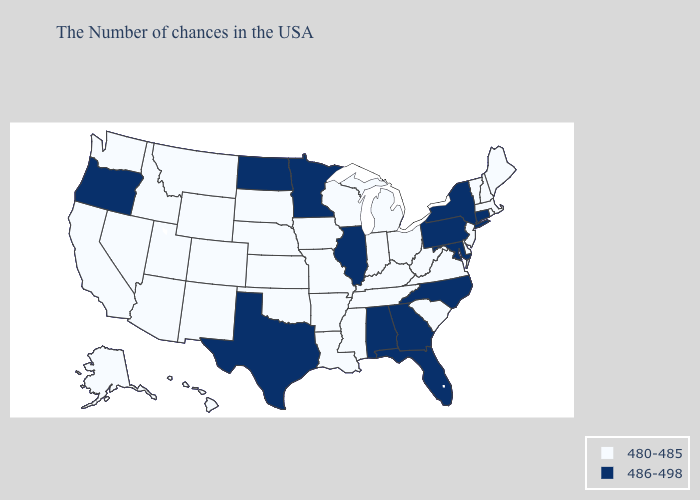Name the states that have a value in the range 486-498?
Quick response, please. Connecticut, New York, Maryland, Pennsylvania, North Carolina, Florida, Georgia, Alabama, Illinois, Minnesota, Texas, North Dakota, Oregon. What is the value of North Dakota?
Be succinct. 486-498. Name the states that have a value in the range 486-498?
Write a very short answer. Connecticut, New York, Maryland, Pennsylvania, North Carolina, Florida, Georgia, Alabama, Illinois, Minnesota, Texas, North Dakota, Oregon. Does the map have missing data?
Keep it brief. No. Does Washington have a lower value than Michigan?
Concise answer only. No. What is the lowest value in states that border Kansas?
Write a very short answer. 480-485. Name the states that have a value in the range 486-498?
Keep it brief. Connecticut, New York, Maryland, Pennsylvania, North Carolina, Florida, Georgia, Alabama, Illinois, Minnesota, Texas, North Dakota, Oregon. Which states have the lowest value in the West?
Answer briefly. Wyoming, Colorado, New Mexico, Utah, Montana, Arizona, Idaho, Nevada, California, Washington, Alaska, Hawaii. Among the states that border Michigan , which have the lowest value?
Concise answer only. Ohio, Indiana, Wisconsin. What is the highest value in states that border Florida?
Short answer required. 486-498. Which states have the lowest value in the MidWest?
Short answer required. Ohio, Michigan, Indiana, Wisconsin, Missouri, Iowa, Kansas, Nebraska, South Dakota. Which states hav the highest value in the MidWest?
Keep it brief. Illinois, Minnesota, North Dakota. Does the first symbol in the legend represent the smallest category?
Concise answer only. Yes. Does the first symbol in the legend represent the smallest category?
Keep it brief. Yes. Which states have the lowest value in the USA?
Concise answer only. Maine, Massachusetts, Rhode Island, New Hampshire, Vermont, New Jersey, Delaware, Virginia, South Carolina, West Virginia, Ohio, Michigan, Kentucky, Indiana, Tennessee, Wisconsin, Mississippi, Louisiana, Missouri, Arkansas, Iowa, Kansas, Nebraska, Oklahoma, South Dakota, Wyoming, Colorado, New Mexico, Utah, Montana, Arizona, Idaho, Nevada, California, Washington, Alaska, Hawaii. 